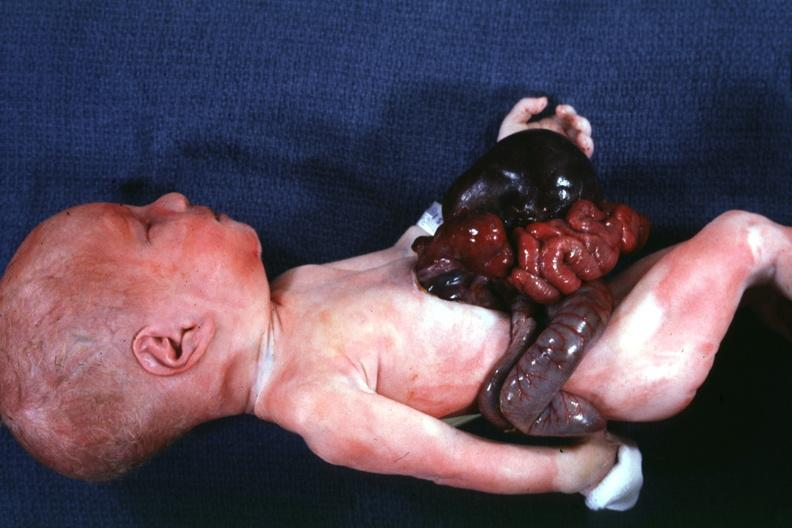does this image show a whole body photo?
Answer the question using a single word or phrase. Yes 